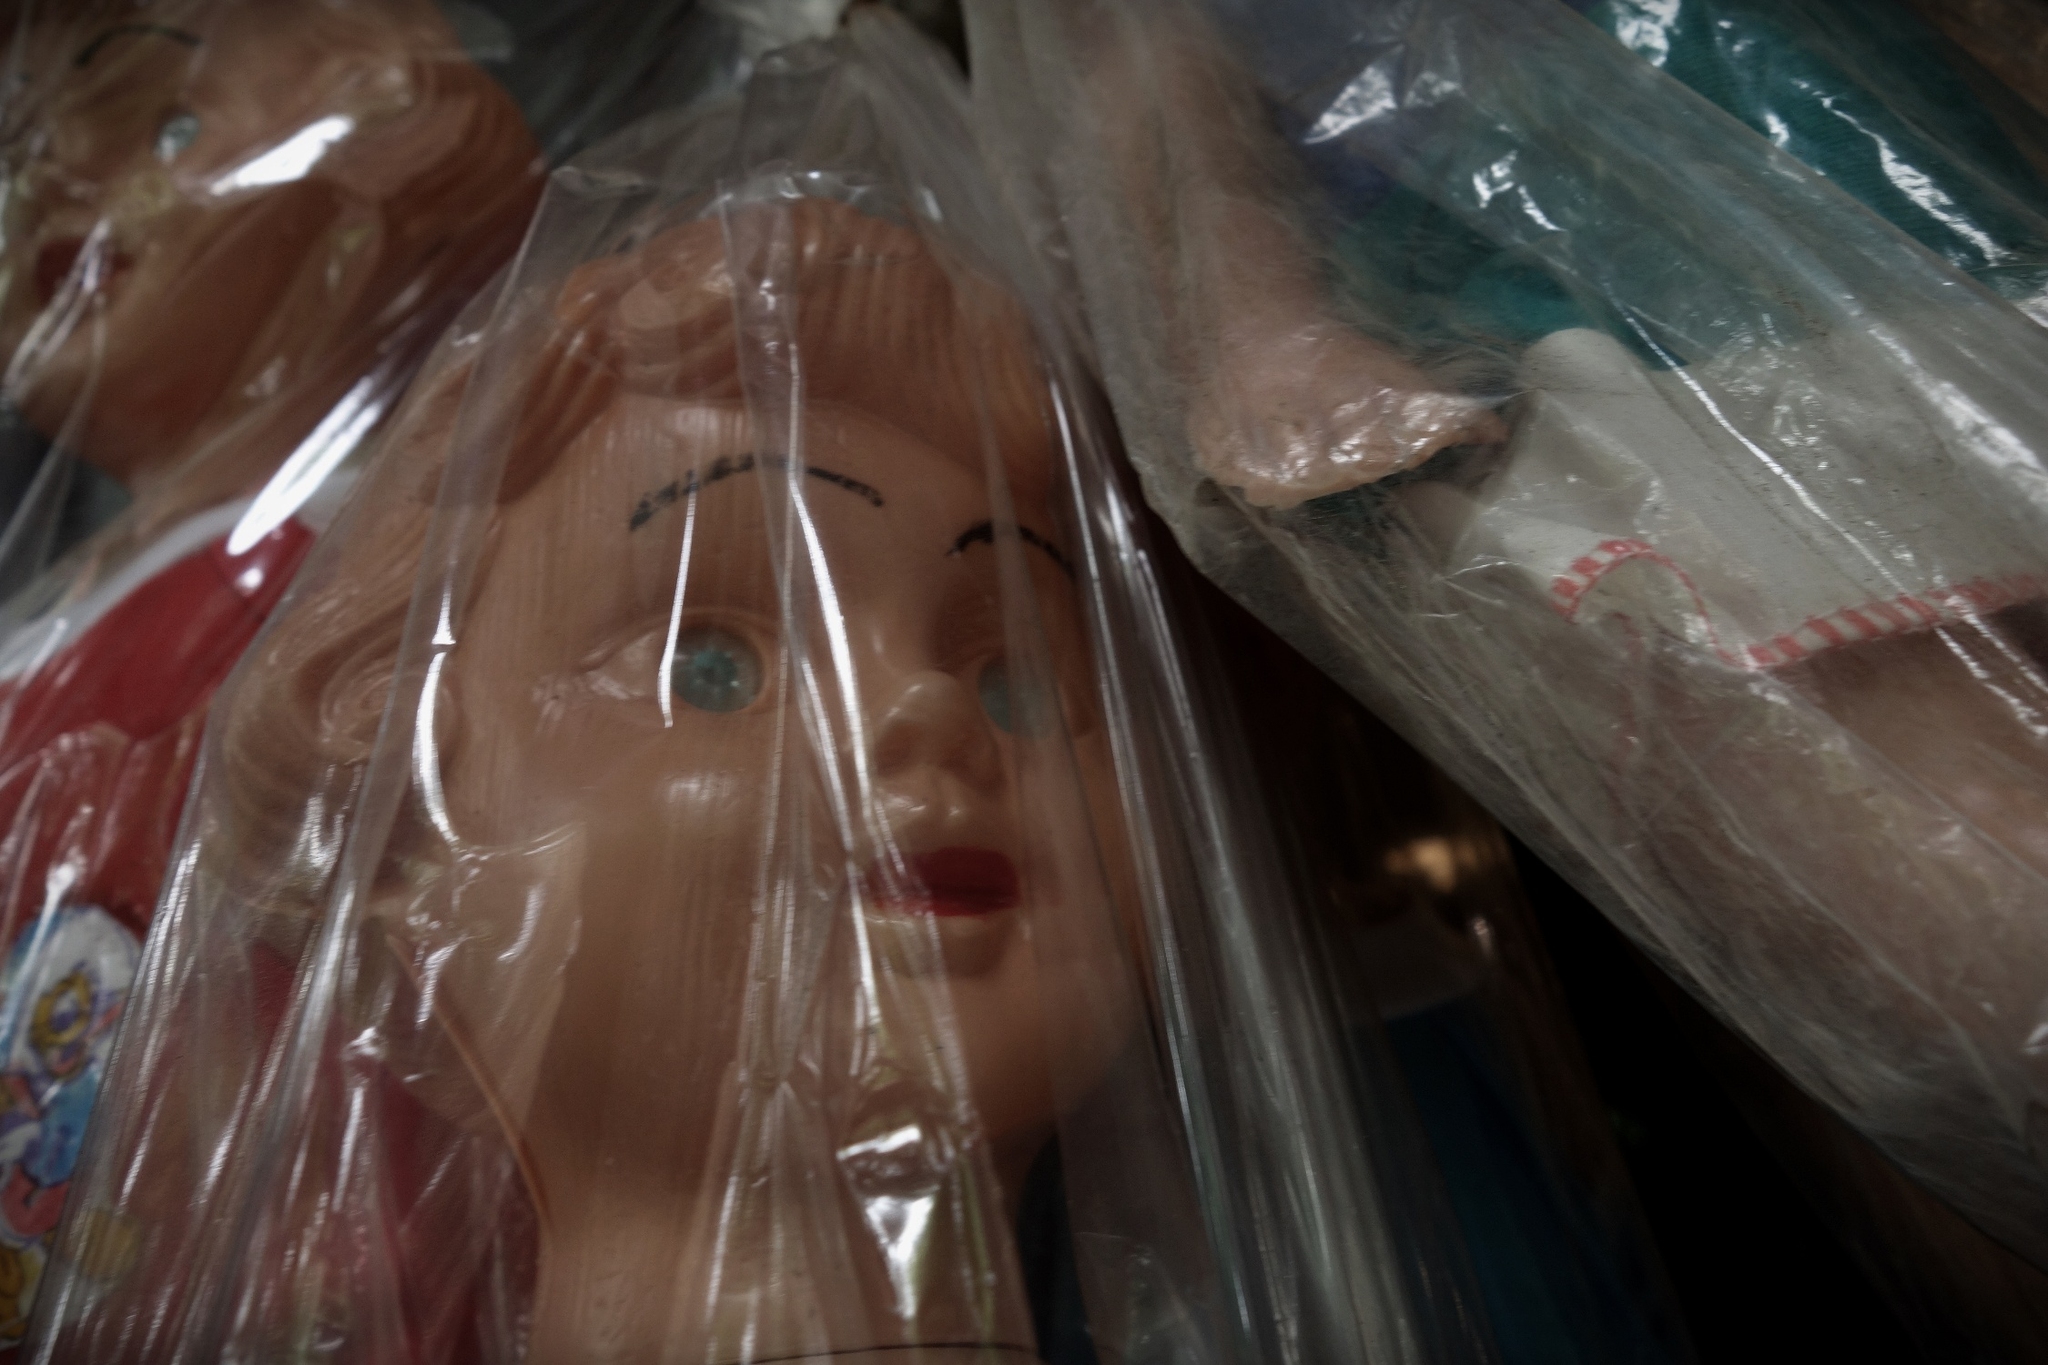Describe the setting where you imagine these dolls are stored. These dolls are likely stored in a carefully controlled environment, perhaps a dedicated room in a collector's home or a museum display. The setting would be dimly lit to prevent damage from light exposure, with shelves or glass cases to organize and display the dolls. The plastic bags provide extra protection, indicating an emphasis on preservation. This setting is a testament to the collector's dedication to maintaining the dolls in their best possible condition. 